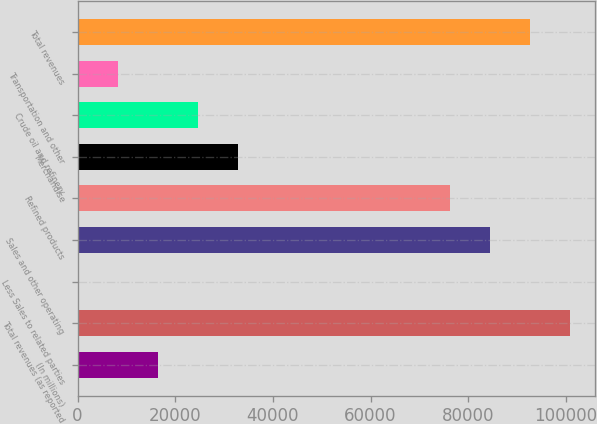Convert chart. <chart><loc_0><loc_0><loc_500><loc_500><bar_chart><fcel>(In millions)<fcel>Total revenues (as reported<fcel>Less Sales to related parties<fcel>Sales and other operating<fcel>Refined products<fcel>Merchandise<fcel>Crude oil and refinery<fcel>Transportation and other<fcel>Total revenues<nl><fcel>16455.4<fcel>100905<fcel>8<fcel>84457.7<fcel>76234<fcel>32902.8<fcel>24679.1<fcel>8231.7<fcel>92681.4<nl></chart> 